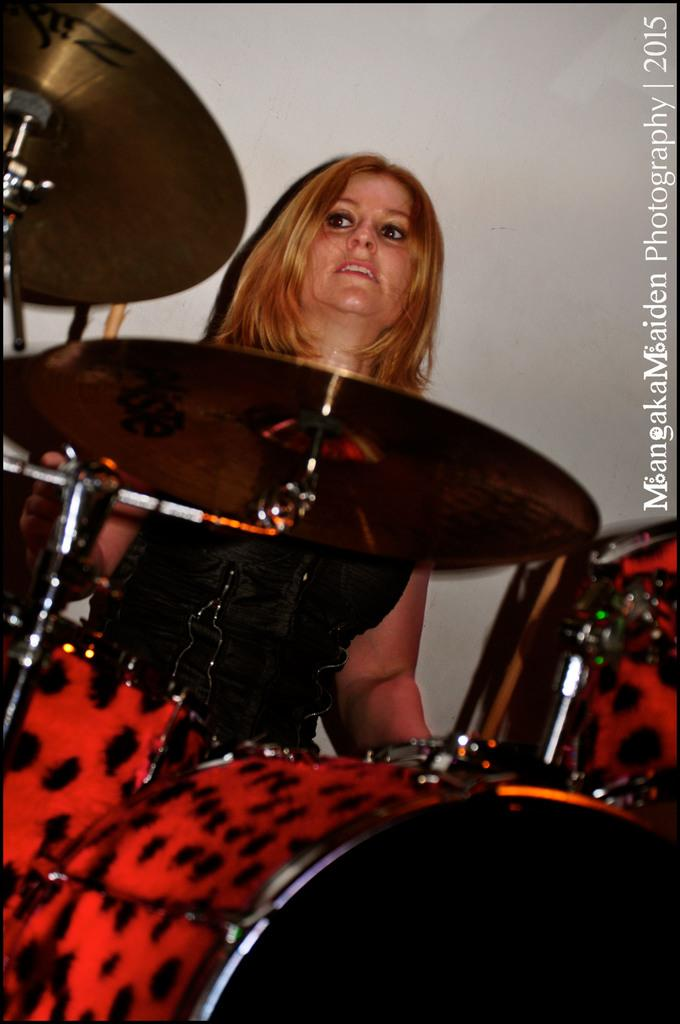Who or what is the main subject in the image? There is a person in the image. What is the person doing or standing near in the image? The person is in front of musical instruments. What can be seen in the background of the image? There is a wall in the background of the image. Where is the text located in the image? The text is on the right side of the image. Can you tell me how many lakes are visible in the image? There are no lakes visible in the image. What type of mountain range can be seen in the background of the image? There is no mountain range present in the image; it features a wall in the background. 